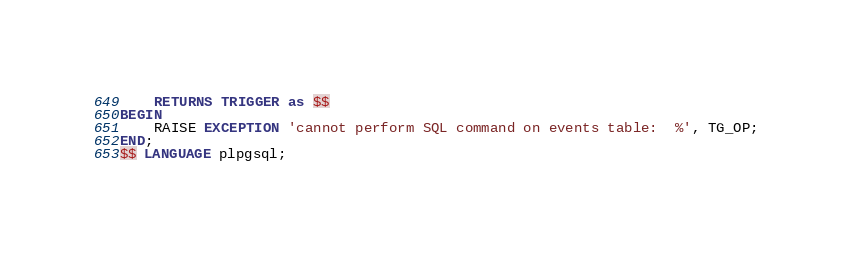Convert code to text. <code><loc_0><loc_0><loc_500><loc_500><_SQL_>	RETURNS TRIGGER as $$
BEGIN
	RAISE EXCEPTION 'cannot perform SQL command on events table:  %', TG_OP;
END;
$$ LANGUAGE plpgsql;
</code> 